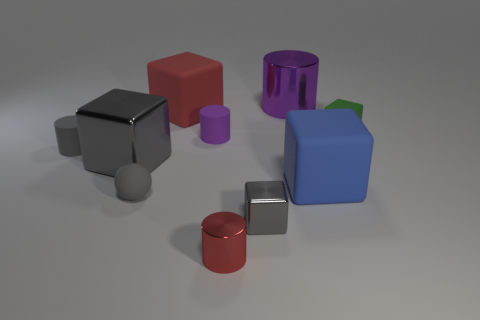There is a rubber thing left of the big metallic block; is its color the same as the small matte sphere?
Your answer should be compact. Yes. There is another cylinder that is the same color as the big cylinder; what is its size?
Provide a short and direct response. Small. Do the matte sphere and the big metallic cube have the same color?
Provide a succinct answer. Yes. Is there another cylinder that has the same color as the large shiny cylinder?
Provide a succinct answer. Yes. There is a big object that is the same color as the small matte sphere; what is its shape?
Ensure brevity in your answer.  Cube. There is a metallic cylinder that is in front of the big purple metallic cylinder; is it the same color as the rubber block that is to the left of the blue cube?
Offer a terse response. Yes. Is the number of large rubber blocks that are on the left side of the small red thing greater than the number of large purple things that are to the left of the big gray object?
Your answer should be very brief. Yes. Are there any small rubber cylinders on the left side of the tiny matte sphere?
Offer a very short reply. Yes. Is there a gray thing of the same size as the red cylinder?
Your answer should be very brief. Yes. What color is the block that is the same material as the big gray object?
Offer a very short reply. Gray. 